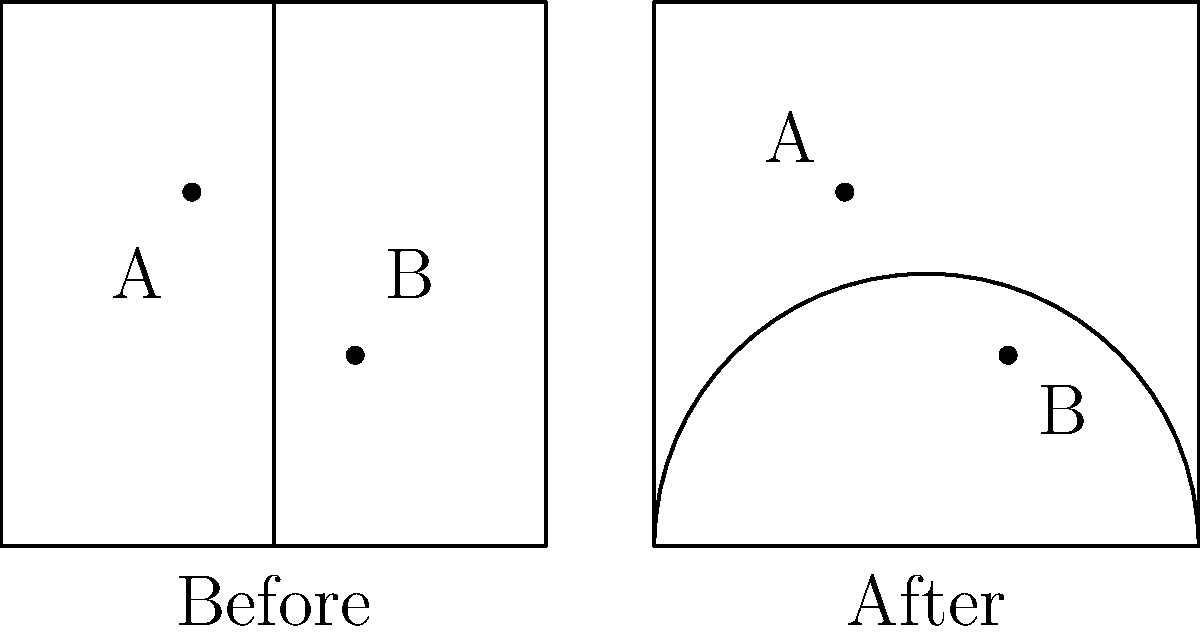In the diagram, two districts (A and B) are shown before and after gerrymandering. Each dot represents 100,000 voters, with blue dots favoring Party X and red dots favoring Party Y. Before gerrymandering, each district had one representative. After gerrymandering, if a district with over 60% of voters favoring one party gains an extra representative, how many total representatives will there be, and what is the percentage increase in representation? Let's approach this step-by-step:

1) Before gerrymandering:
   - District A: 1 blue dot (100,000 voters for Party X)
   - District B: 1 red dot (100,000 voters for Party Y)
   - Total representatives: 2 (1 for each district)

2) After gerrymandering:
   - District A: 2 blue dots (200,000 voters for Party X)
   - District B: 2 red dots (200,000 voters for Party Y)

3) Calculate the percentage of voters in each district:
   - District A: 200,000 / 200,000 = 100% for Party X
   - District B: 200,000 / 200,000 = 100% for Party Y

4) Both districts now have over 60% of voters favoring one party, so they each gain an extra representative.

5) New total representatives:
   - District A: 2 representatives
   - District B: 2 representatives
   - Total: 4 representatives

6) Calculate the percentage increase:
   - Original number of representatives: 2
   - New number of representatives: 4
   - Increase: 4 - 2 = 2
   - Percentage increase: (2 / 2) * 100 = 100%

Therefore, after gerrymandering, there will be 4 total representatives, which is a 100% increase in representation.
Answer: 4 representatives; 100% increase 